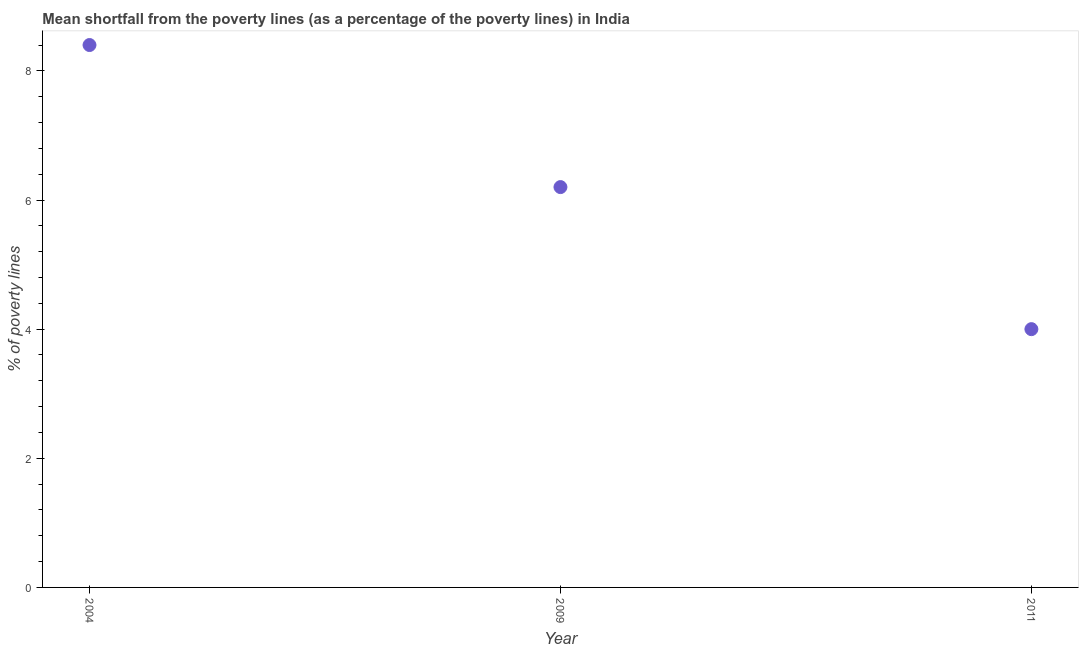What is the poverty gap at national poverty lines in 2004?
Provide a short and direct response. 8.4. Across all years, what is the maximum poverty gap at national poverty lines?
Your answer should be very brief. 8.4. In which year was the poverty gap at national poverty lines maximum?
Give a very brief answer. 2004. What is the sum of the poverty gap at national poverty lines?
Offer a terse response. 18.6. What is the difference between the poverty gap at national poverty lines in 2004 and 2009?
Give a very brief answer. 2.2. What is the median poverty gap at national poverty lines?
Offer a very short reply. 6.2. In how many years, is the poverty gap at national poverty lines greater than 7.2 %?
Your answer should be very brief. 1. What is the ratio of the poverty gap at national poverty lines in 2009 to that in 2011?
Provide a short and direct response. 1.55. Is the difference between the poverty gap at national poverty lines in 2009 and 2011 greater than the difference between any two years?
Ensure brevity in your answer.  No. What is the difference between the highest and the lowest poverty gap at national poverty lines?
Offer a terse response. 4.4. In how many years, is the poverty gap at national poverty lines greater than the average poverty gap at national poverty lines taken over all years?
Make the answer very short. 1. Does the poverty gap at national poverty lines monotonically increase over the years?
Ensure brevity in your answer.  No. How many dotlines are there?
Your answer should be compact. 1. How many years are there in the graph?
Keep it short and to the point. 3. What is the difference between two consecutive major ticks on the Y-axis?
Provide a succinct answer. 2. Are the values on the major ticks of Y-axis written in scientific E-notation?
Your answer should be very brief. No. Does the graph contain grids?
Provide a succinct answer. No. What is the title of the graph?
Keep it short and to the point. Mean shortfall from the poverty lines (as a percentage of the poverty lines) in India. What is the label or title of the X-axis?
Offer a terse response. Year. What is the label or title of the Y-axis?
Keep it short and to the point. % of poverty lines. What is the % of poverty lines in 2004?
Your answer should be compact. 8.4. What is the difference between the % of poverty lines in 2004 and 2009?
Give a very brief answer. 2.2. What is the ratio of the % of poverty lines in 2004 to that in 2009?
Your response must be concise. 1.35. What is the ratio of the % of poverty lines in 2009 to that in 2011?
Provide a short and direct response. 1.55. 